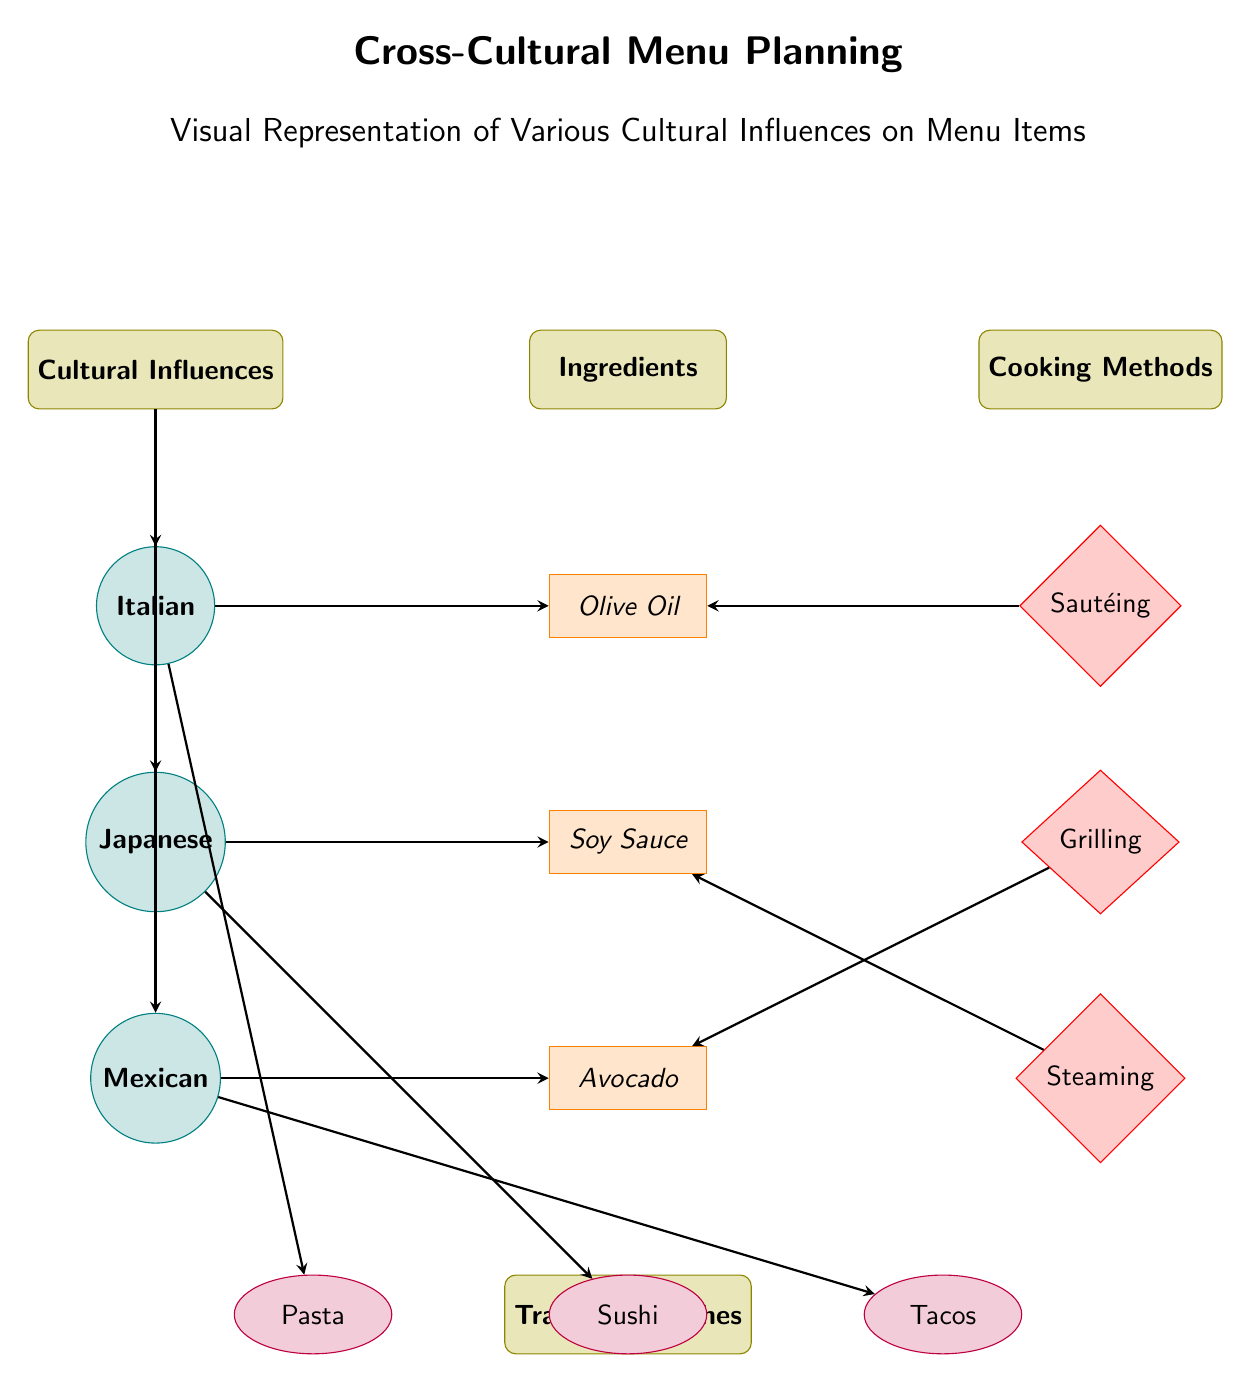What are the three cultures represented in the diagram? The diagram shows three cultures: Italian, Japanese, and Mexican. These are connected to the "Cultural Influences" category in the diagram.
Answer: Italian, Japanese, Mexican How many cooking methods are listed in the diagram? There are three cooking methods identified in the diagram: Sautéing, Grilling, and Steaming. They are connected to the "Cooking Methods" category.
Answer: 3 Which ingredient is associated with the Japanese culture? The Japanese culture is linked to Soy Sauce in the diagram, as indicated by the arrow connecting them.
Answer: Soy Sauce What traditional dish corresponds to the Mexican culture? Tacos is the traditional dish associated with the Mexican culture, as shown by the direct connection between them in the diagram.
Answer: Tacos Which ingredient is used in the cooking method of sautéing? Olive Oil is the ingredient that connects to the cooking method of Sautéing in the diagram, indicated by the arrow pointing from Sautéing to Olive Oil.
Answer: Olive Oil What type of method is used for cooking Avocado according to the diagram? The diagram indicates that Grilling is the cooking method associated with Avocado, as shown by the arrow from Grilling leading to Avocado.
Answer: Grilling How many traditional dishes are outlined in the diagram? The diagram outlines three traditional dishes: Pasta, Sushi, and Tacos. They are presented under the "Traditional Dishes" category.
Answer: 3 Which cultural influence uses Steaming as a cooking method? The Japanese culture uses Steaming as its associated cooking method, as indicated by the connection in the diagram.
Answer: Japanese What is the relationship between Italian culture and the traditional dish mentioned? The Italian culture is directly linked to Pasta in the diagram, demonstrating that Pasta is a key traditional dish for Italian cuisine.
Answer: Pasta 